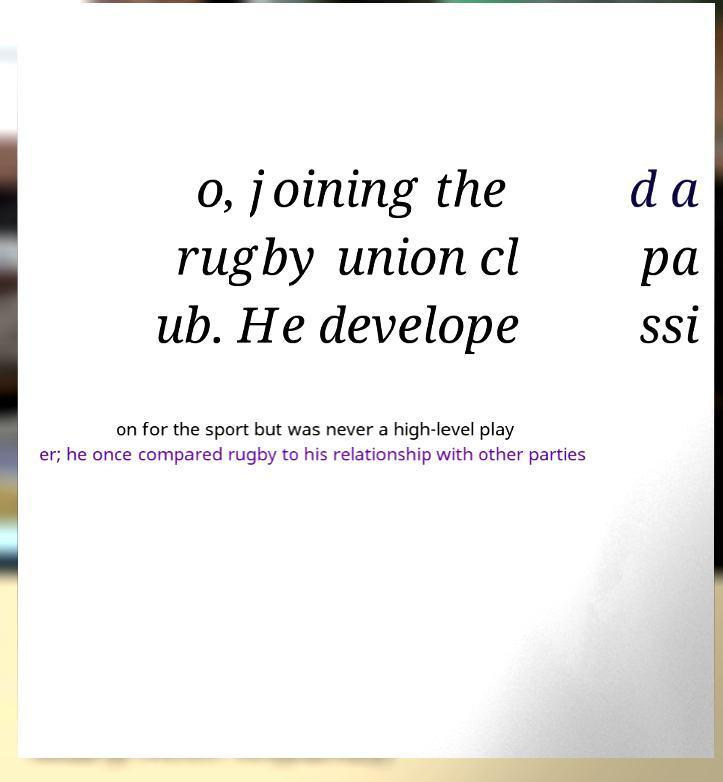For documentation purposes, I need the text within this image transcribed. Could you provide that? o, joining the rugby union cl ub. He develope d a pa ssi on for the sport but was never a high-level play er; he once compared rugby to his relationship with other parties 